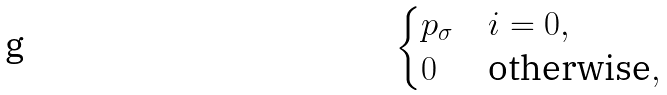Convert formula to latex. <formula><loc_0><loc_0><loc_500><loc_500>\begin{cases} p _ { \sigma } & \text {$i = 0$} , \\ 0 & \text {otherwise} , \end{cases}</formula> 